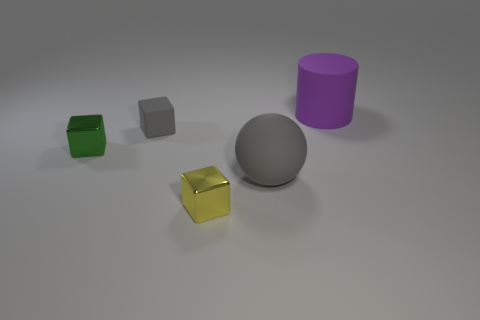Subtract all yellow spheres. Subtract all cyan blocks. How many spheres are left? 1 Add 3 gray balls. How many objects exist? 8 Subtract all balls. How many objects are left? 4 Add 3 big gray matte balls. How many big gray matte balls exist? 4 Subtract 0 gray cylinders. How many objects are left? 5 Subtract all small gray rubber cylinders. Subtract all balls. How many objects are left? 4 Add 1 small gray objects. How many small gray objects are left? 2 